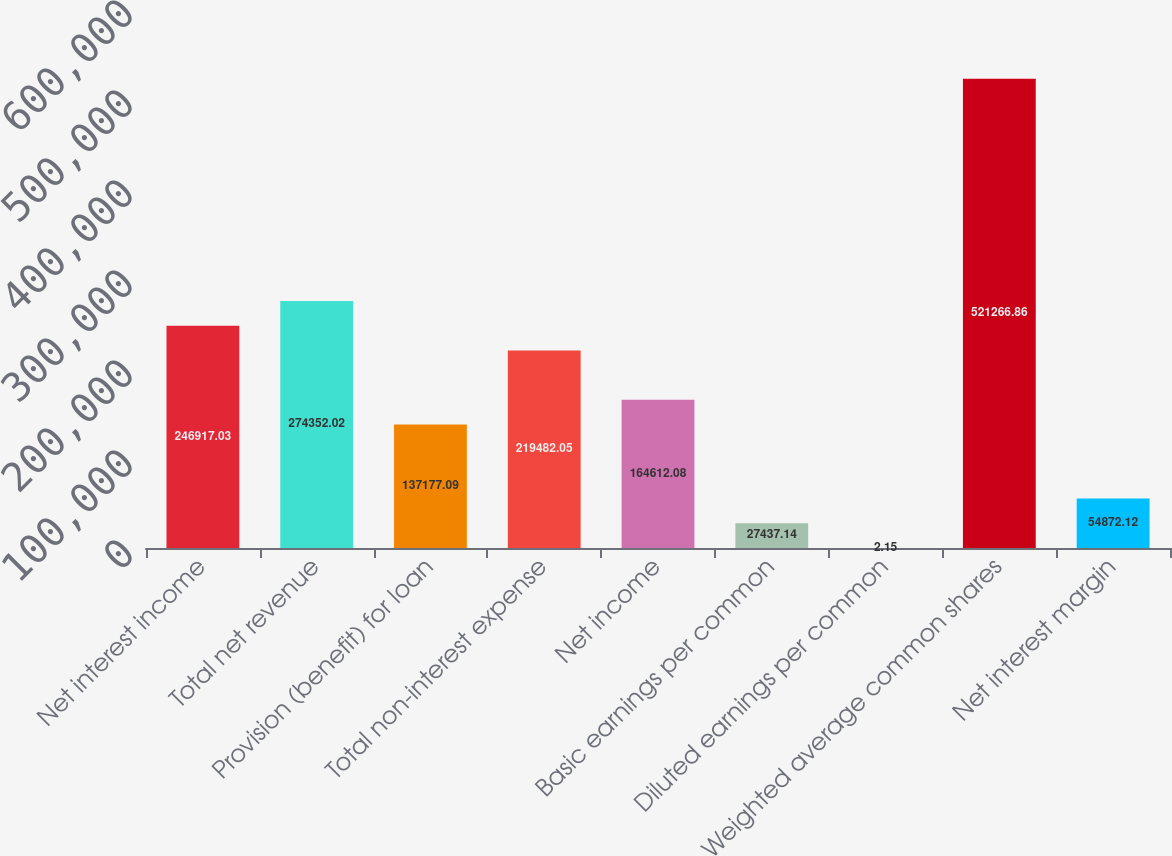Convert chart to OTSL. <chart><loc_0><loc_0><loc_500><loc_500><bar_chart><fcel>Net interest income<fcel>Total net revenue<fcel>Provision (benefit) for loan<fcel>Total non-interest expense<fcel>Net income<fcel>Basic earnings per common<fcel>Diluted earnings per common<fcel>Weighted average common shares<fcel>Net interest margin<nl><fcel>246917<fcel>274352<fcel>137177<fcel>219482<fcel>164612<fcel>27437.1<fcel>2.15<fcel>521267<fcel>54872.1<nl></chart> 